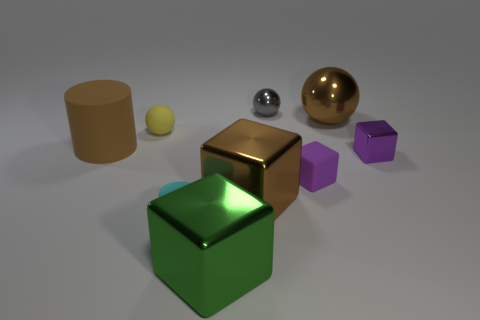Subtract all brown metal blocks. How many blocks are left? 3 Subtract all cyan cylinders. How many purple cubes are left? 2 Subtract 2 blocks. How many blocks are left? 2 Add 1 large shiny cubes. How many objects exist? 10 Subtract all brown blocks. How many blocks are left? 3 Subtract all blue blocks. Subtract all red balls. How many blocks are left? 4 Subtract all cubes. How many objects are left? 5 Subtract all brown cubes. Subtract all large cylinders. How many objects are left? 7 Add 7 big brown cylinders. How many big brown cylinders are left? 8 Add 1 big brown matte spheres. How many big brown matte spheres exist? 1 